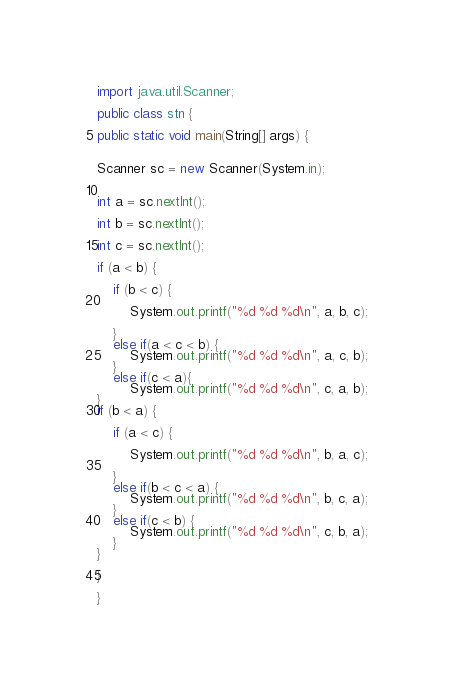<code> <loc_0><loc_0><loc_500><loc_500><_Java_>import java.util.Scanner;

public class stn {

public static void main(String[] args) {


Scanner sc = new Scanner(System.in);


int a = sc.nextInt();

int b = sc.nextInt();

int c = sc.nextInt();

if (a < b) {

	if (b < c) {

		System.out.printf("%d %d %d\n", a, b, c);

	}
	else if(a < c < b) {
		System.out.printf("%d %d %d\n", a, c, b);
	}
	else if(c < a){
		System.out.printf("%d %d %d\n", c, a, b);
}
if (b < a) {

	if (a < c) {

		System.out.printf("%d %d %d\n", b, a, c);

	}
	else if(b < c < a) {
		System.out.printf("%d %d %d\n", b, c, a);
	}
	else if(c < b) {
		System.out.printf("%d %d %d\n", c, b, a);
	}
}

}

}</code> 